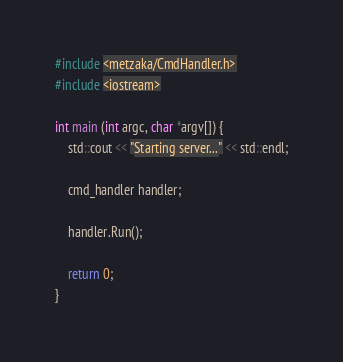Convert code to text. <code><loc_0><loc_0><loc_500><loc_500><_C++_>#include <metzaka/CmdHandler.h>
#include <iostream>

int main (int argc, char *argv[]) {
    std::cout << "Starting server..." << std::endl;

    cmd_handler handler;
    
    handler.Run();

    return 0;
}</code> 